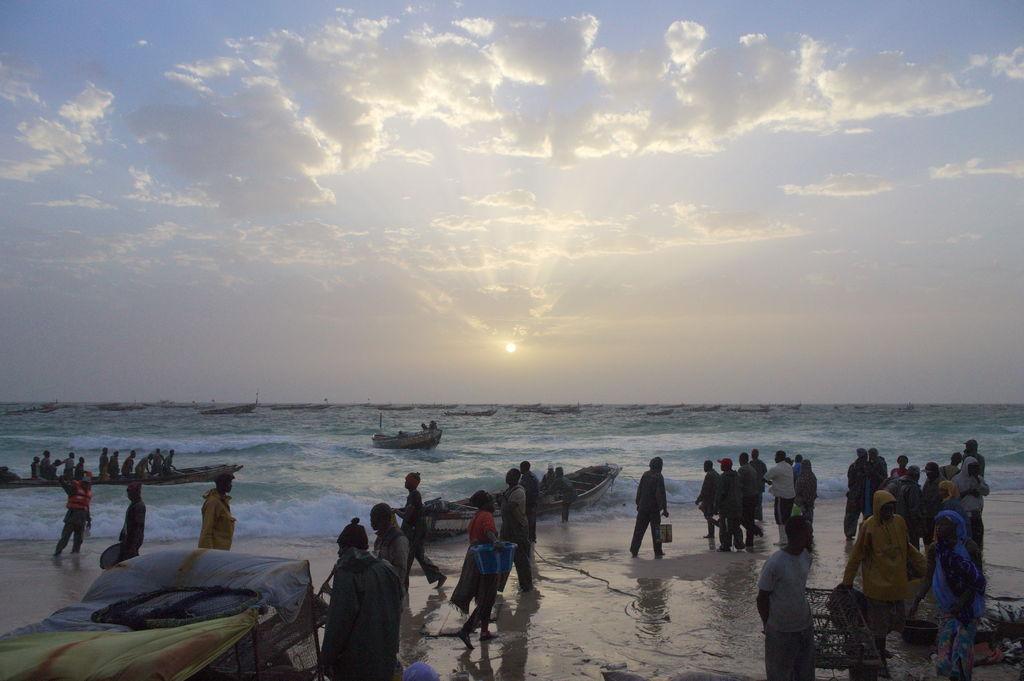In one or two sentences, can you explain what this image depicts? In this image I can see group of people some are walking and some are standing. I can also see few boats on the water, background I can see sky in blue and white color. 